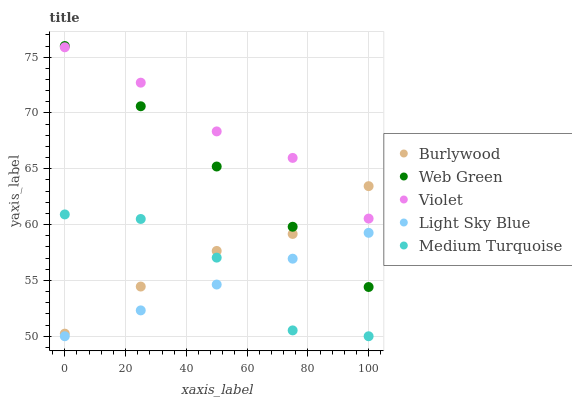Does Light Sky Blue have the minimum area under the curve?
Answer yes or no. Yes. Does Violet have the maximum area under the curve?
Answer yes or no. Yes. Does Medium Turquoise have the minimum area under the curve?
Answer yes or no. No. Does Medium Turquoise have the maximum area under the curve?
Answer yes or no. No. Is Light Sky Blue the smoothest?
Answer yes or no. Yes. Is Medium Turquoise the roughest?
Answer yes or no. Yes. Is Medium Turquoise the smoothest?
Answer yes or no. No. Is Light Sky Blue the roughest?
Answer yes or no. No. Does Light Sky Blue have the lowest value?
Answer yes or no. Yes. Does Web Green have the lowest value?
Answer yes or no. No. Does Web Green have the highest value?
Answer yes or no. Yes. Does Medium Turquoise have the highest value?
Answer yes or no. No. Is Medium Turquoise less than Violet?
Answer yes or no. Yes. Is Violet greater than Light Sky Blue?
Answer yes or no. Yes. Does Burlywood intersect Web Green?
Answer yes or no. Yes. Is Burlywood less than Web Green?
Answer yes or no. No. Is Burlywood greater than Web Green?
Answer yes or no. No. Does Medium Turquoise intersect Violet?
Answer yes or no. No. 